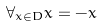Convert formula to latex. <formula><loc_0><loc_0><loc_500><loc_500>\forall _ { x \in D } x = - x</formula> 